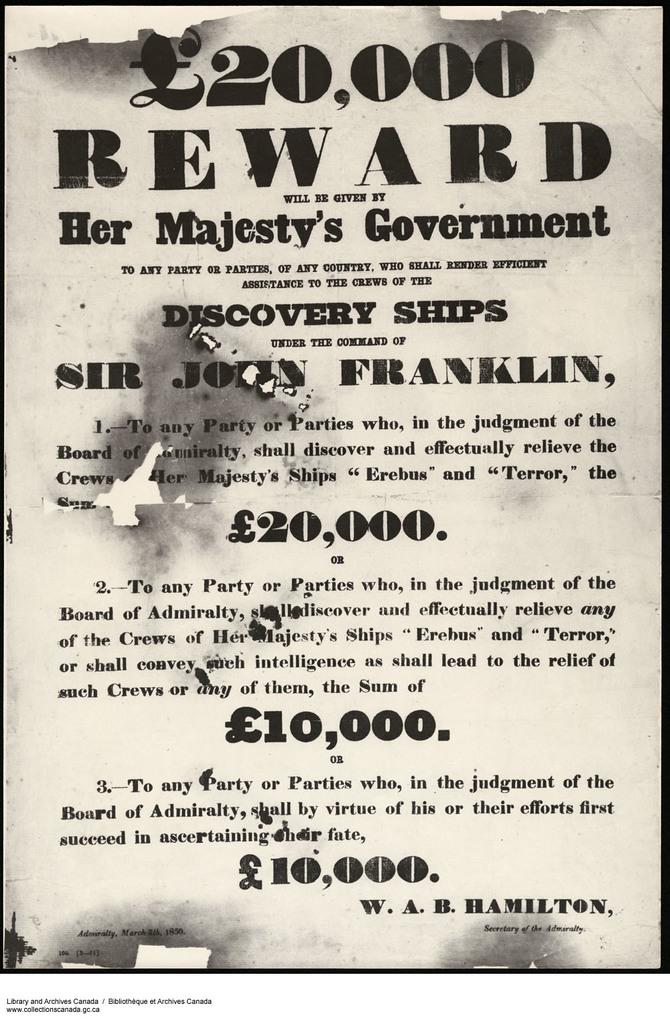<image>
Provide a brief description of the given image. A reward of 20,000 pounds will be given by Her Majesty's government. 